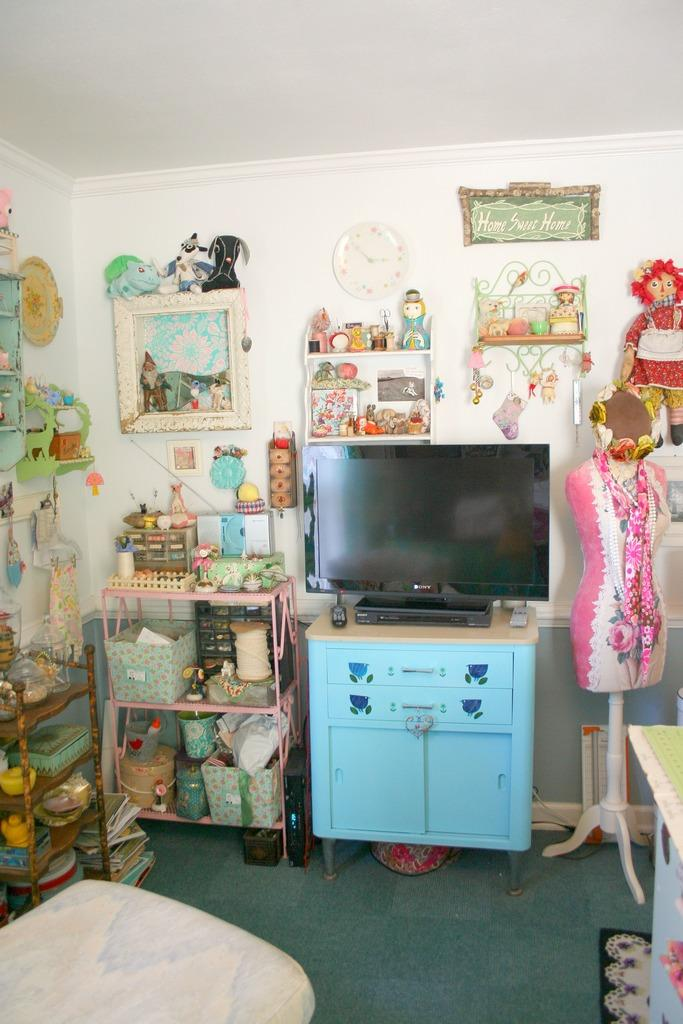<image>
Summarize the visual content of the image. Room with a Sony television on top of a blue drawer. 